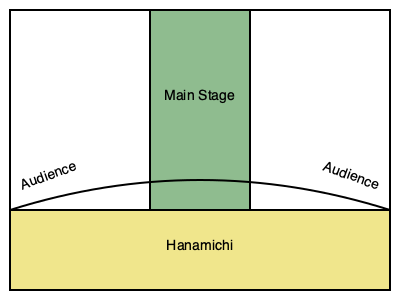In the context of kabuki theater stage layouts during feudal Japan, what cultural influence is most evident in the inclusion and positioning of the hanamichi, and how does it reflect the social structure of the time? 1. The hanamichi, represented in the diagram as the long runway extending from the main stage into the audience area, is a unique feature of kabuki theater.

2. Its positioning reflects the importance of processional elements in Japanese culture, particularly in feudal society where formal entrances and exits were highly ritualized.

3. The hanamichi serves as a bridge between the world of the play (the main stage) and the world of the audience, mirroring the fluid boundaries between performers and spectators in Japanese society.

4. The elevated nature of the hanamichi (as indicated by the curved line in the diagram) symbolizes the hierarchical structure of feudal Japan, with performers literally and figuratively above the audience.

5. Its extension into the audience area allows for more intimate interactions between actors and spectators, reflecting the participatory nature of Japanese theatrical traditions.

6. The hanamichi's positioning also allows for dramatic entrances and exits, emphasizing the importance of individual character development in kabuki, which was influenced by the samurai culture's focus on personal honor and reputation.

7. The cultural significance of the hanamichi is further emphasized by its use for mie poses, dramatic freeze-frame moments that showcase an actor's prowess, reflecting the value placed on individual skill and artistry in Japanese society.
Answer: Hierarchical social structure and processional culture 